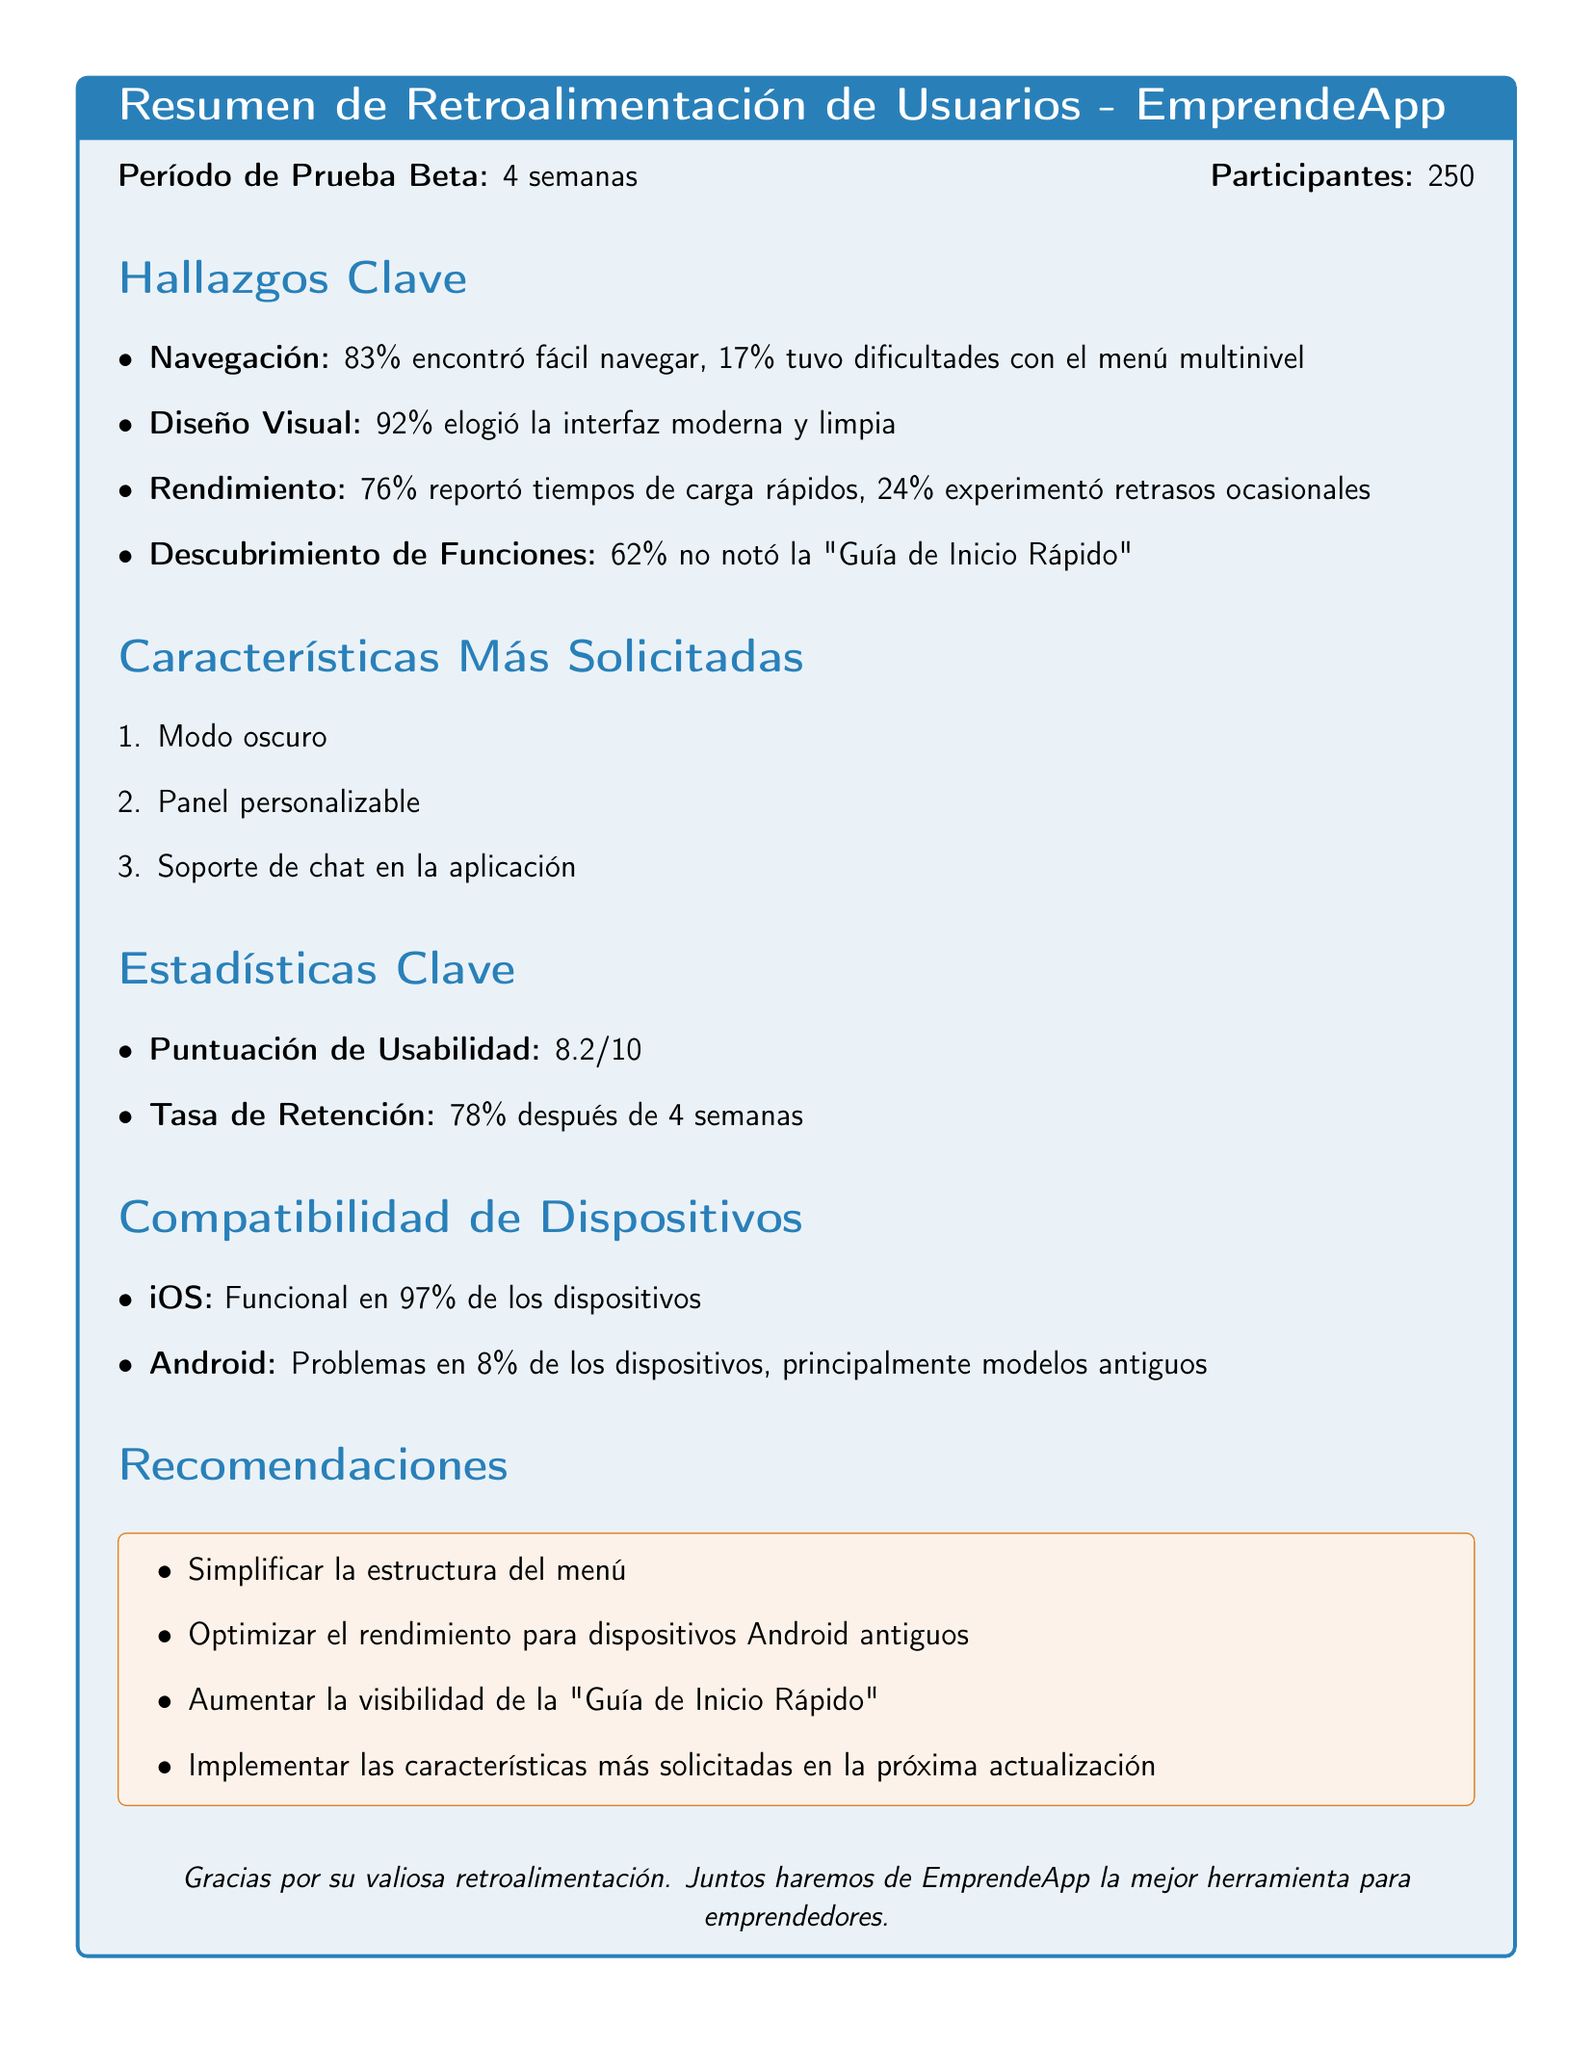what is the name of the app being tested? The document identifies the app being tested as EmprendeApp.
Answer: EmprendeApp how long was the beta testing period? The document states that the beta testing period lasted for 4 weeks.
Answer: 4 weeks what percentage of users found the app easy to navigate? According to the findings, 83% of users found the app easy to navigate.
Answer: 83% what are the top requested features by users? The document lists the top requested features as dark mode option, customizable dashboard, and in-app chat support.
Answer: Dark mode option, customizable dashboard, in-app chat support what was the usability score given by users? The usability score mentioned in the document is 8.2 out of 10.
Answer: 8.2 how many total participants were involved in the beta test? The total number of participants involved in the beta test, as stated in the document, is 250.
Answer: 250 what percentage of users missed the 'Quick Start Guide' feature? The document indicates that 62% of users missed the 'Quick Start Guide' feature.
Answer: 62% what percentage of Android devices experienced compatibility issues? The document reports that 8% of Android devices experienced compatibility issues.
Answer: 8% what is one recommendation given in the document? The recommendations include simplifying the menu structure, which is one of several suggestions provided.
Answer: Simplify menu structure 